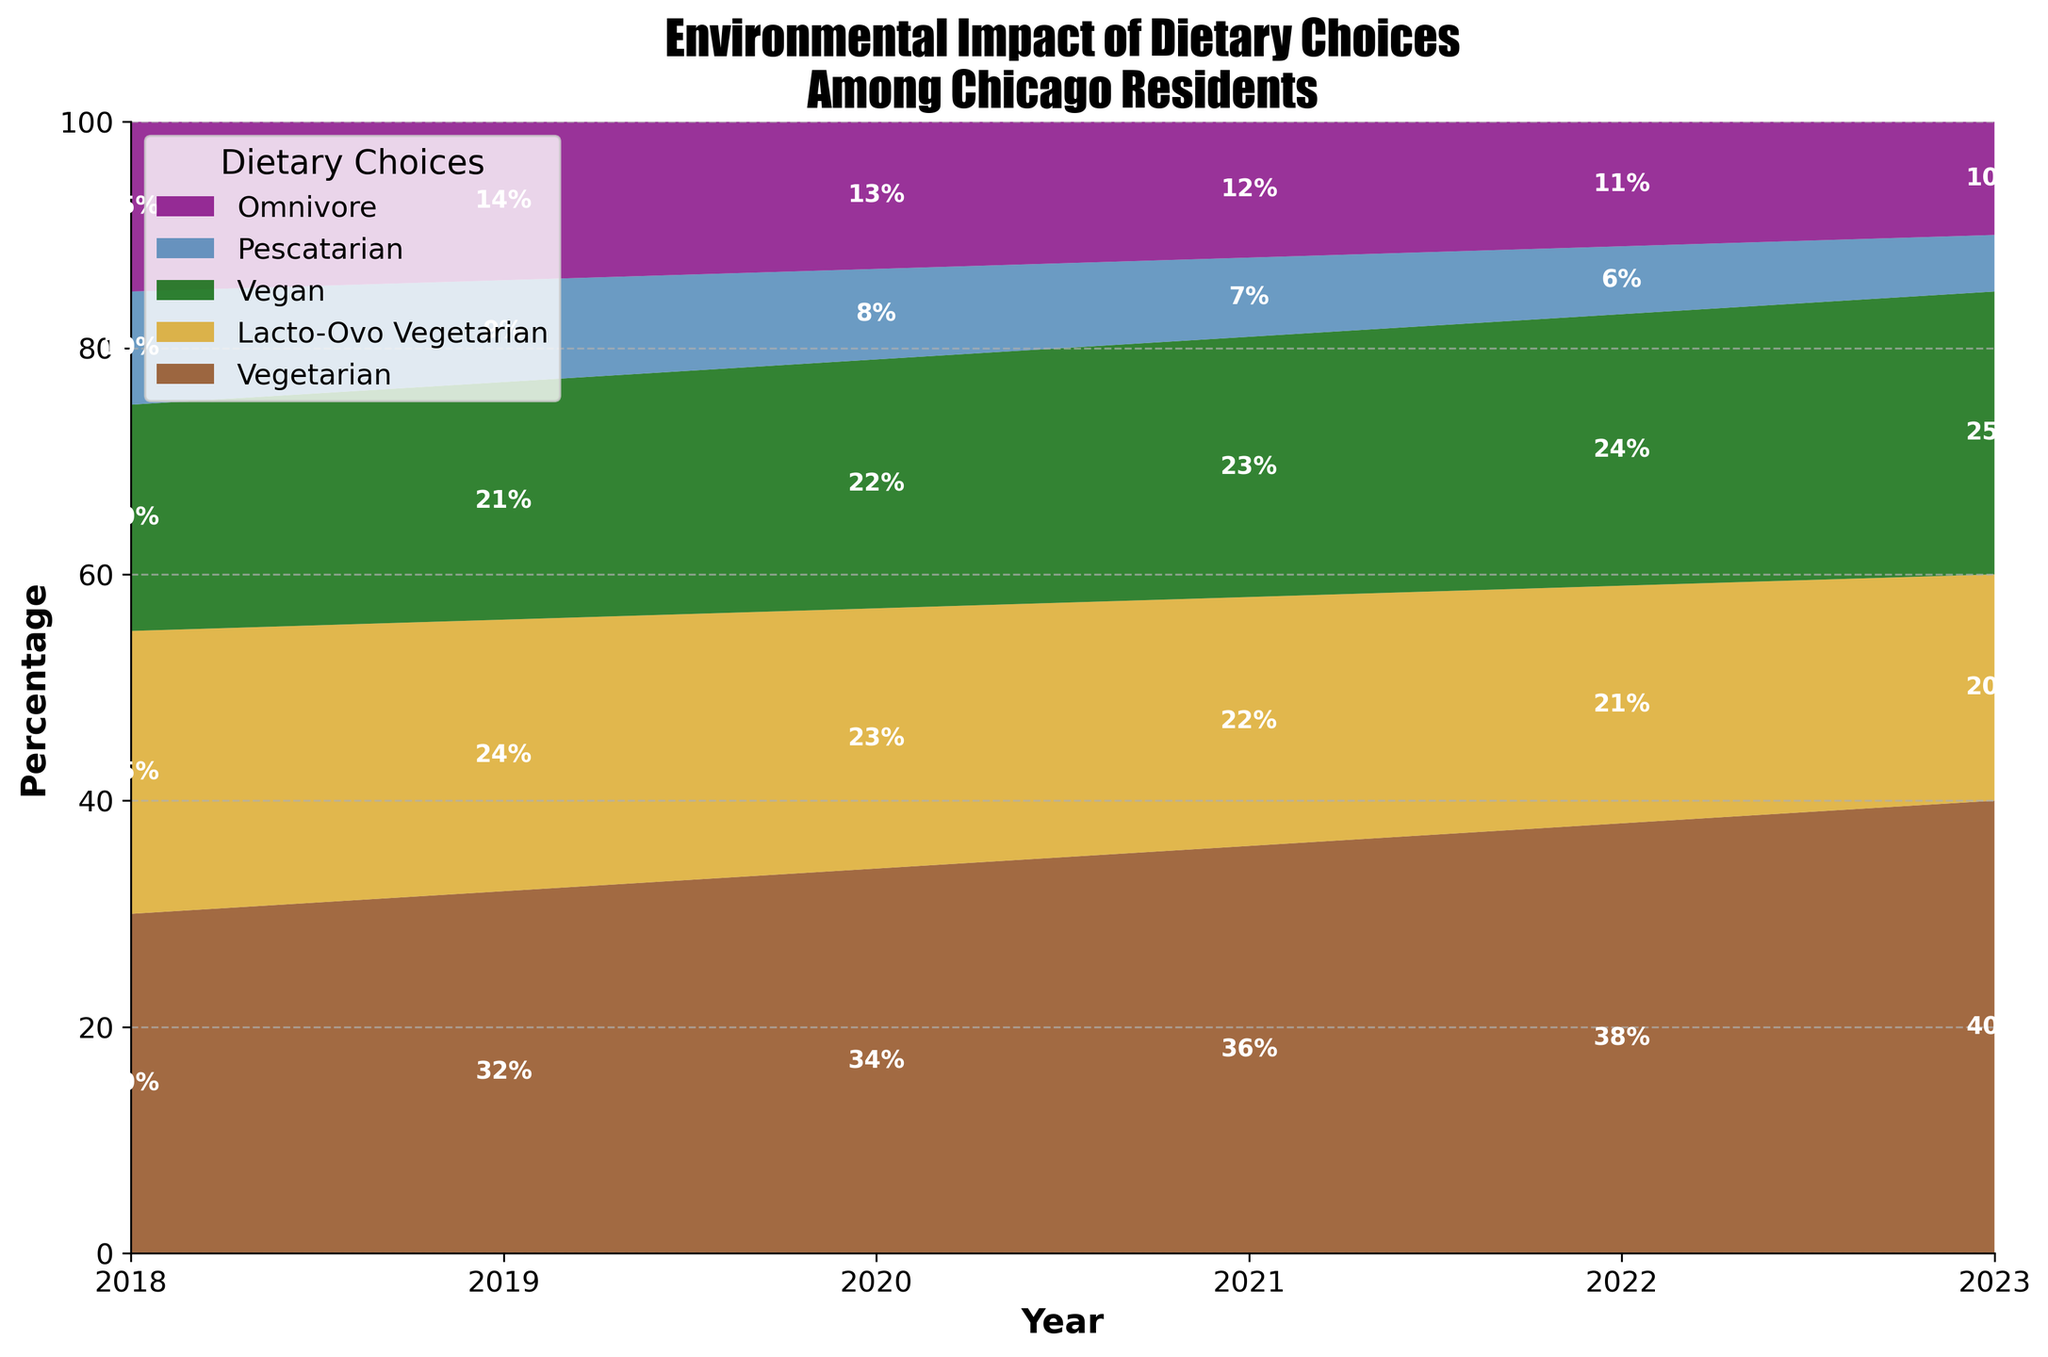What's the title of the figure? The title of the figure is written at the top of the chart in bold and large font.
Answer: Environmental Impact of Dietary Choices Among Chicago Residents Which dietary choice had the highest percentage in 2023? Look at the top section of the 2023 stack. The section with the highest position is labeled "Vegetarian".
Answer: Vegetarian What's the percentage of Vegans in 2020? Find the "Vegan" section in the 2020 stack. The percentage is written within the section.
Answer: 22% How did the percentage of Vegetarians change from 2018 to 2023? Compare the heights of the "Vegetarian" section in 2018 and 2023 by looking at their positions on the Y-axis. In 2018, it is 30%, and in 2023, it is 40%. The difference is 40% - 30%.
Answer: Increased by 10% Between which years did Omnivores' percentage drop the most? Compare the changes in the "Omnivore" section for each adjacent year. The drop from 2018 (15%) to 2019 (14%), from 2019 to 2020 (13%), from 2020 to 2021 (12%), from 2021 to 2022 (11%), and from 2022 to 2023 (10%). The largest drop is from 2019 to 2020.
Answer: 2019 to 2020 Calculate the total percentage of Vegetarian and Vegan dietary choices in 2022. Add the percentages of "Vegetarian" and "Vegan" sections in 2022. Vegetarian is 38% and Vegan is 24%.
Answer: 62% Which dietary choice consistently declined over the years? Observe the trends for each dietary choice from 2018 to 2023. Identify which one consistently has decreased.
Answer: Omnivore What is the difference in percentage between Lacto-Ovo Vegetarians and Pescatarians in 2021? Look at the "Lacto-Ovo Vegetarian" and "Pescatarian" sections in 2021. Lacto-Ovo Vegetarians are at 22% and Pescatarians are at 7%. Subtract 7% from 22%.
Answer: 15% Which dietary choice had a higher percentage in 2020: Vegan or Pescatarian? Compare the heights of the "Vegan" and "Pescatarian" sections in 2020. The Vegan section is at 22%, while the Pescatarian section is at 8%.
Answer: Vegan What trend can you observe for the Pescatarian dietary choice from 2018 to 2023? Look at the "Pescatarian" sections from 2018 to 2023 and note if they are increasing, decreasing, or stable. The percentages are 10%, 9%, 8%, 7%, 6%, and 5% respectively.
Answer: Decreasing 